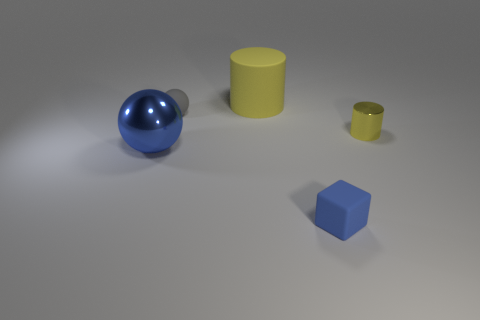How many yellow cylinders must be subtracted to get 1 yellow cylinders? 1 Subtract 1 spheres. How many spheres are left? 1 Subtract all cubes. How many objects are left? 4 Subtract all yellow cylinders. How many gray spheres are left? 1 Subtract all small yellow shiny spheres. Subtract all small yellow shiny objects. How many objects are left? 4 Add 5 small yellow shiny things. How many small yellow shiny things are left? 6 Add 4 large yellow objects. How many large yellow objects exist? 5 Add 1 small yellow things. How many objects exist? 6 Subtract all blue spheres. How many spheres are left? 1 Subtract 0 purple cubes. How many objects are left? 5 